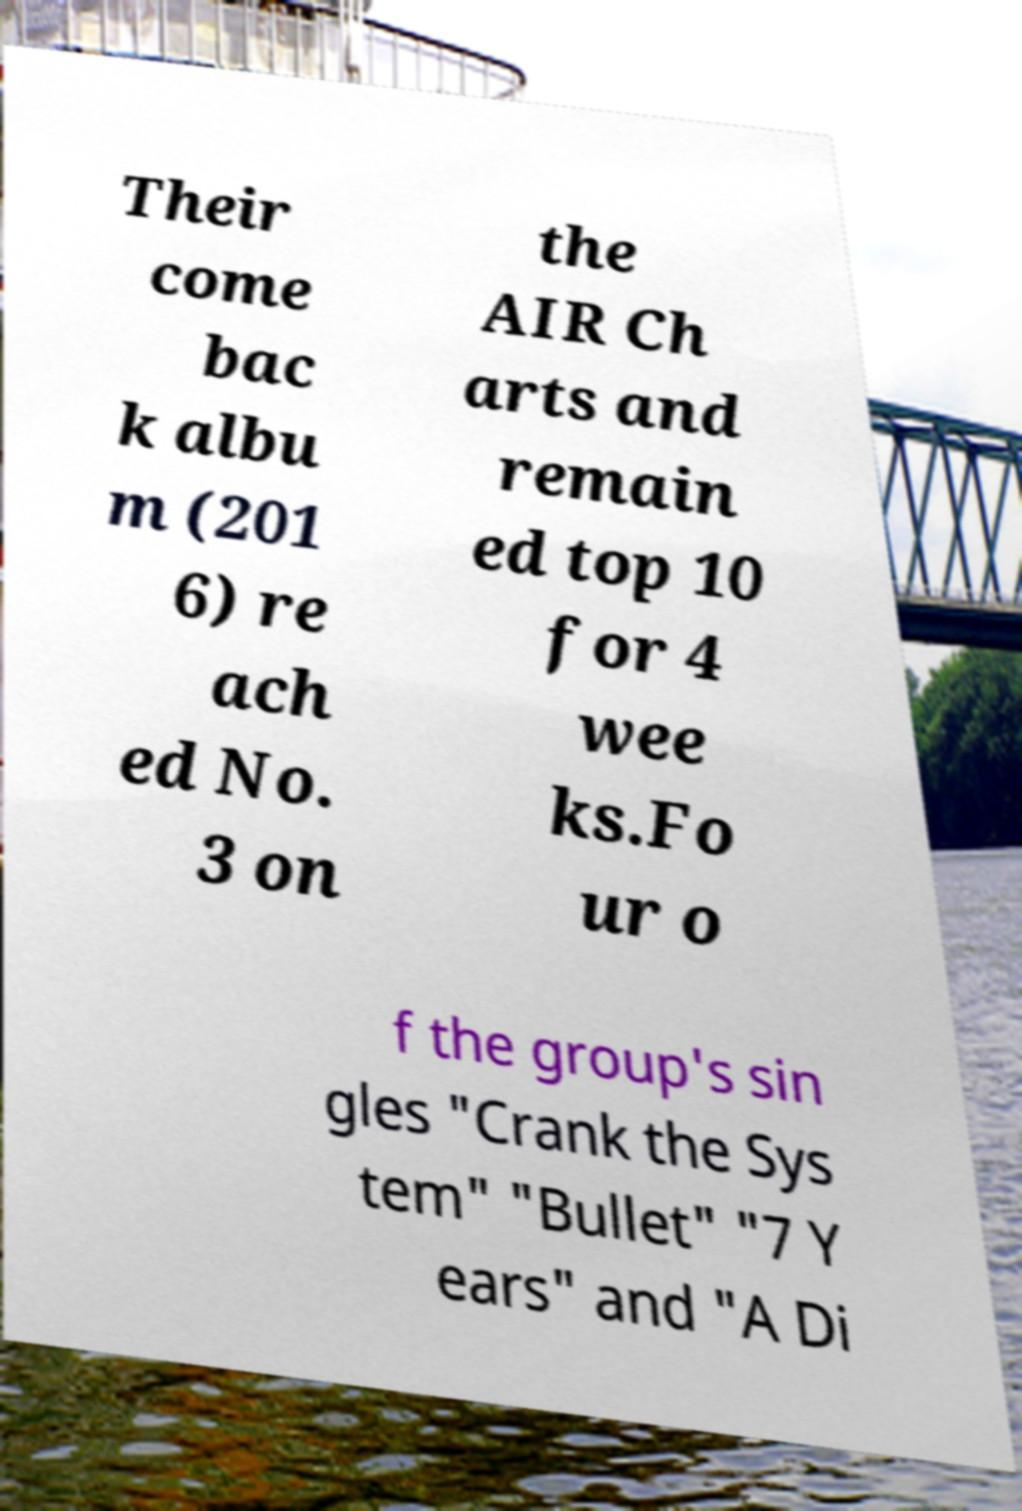Can you accurately transcribe the text from the provided image for me? Their come bac k albu m (201 6) re ach ed No. 3 on the AIR Ch arts and remain ed top 10 for 4 wee ks.Fo ur o f the group's sin gles "Crank the Sys tem" "Bullet" "7 Y ears" and "A Di 